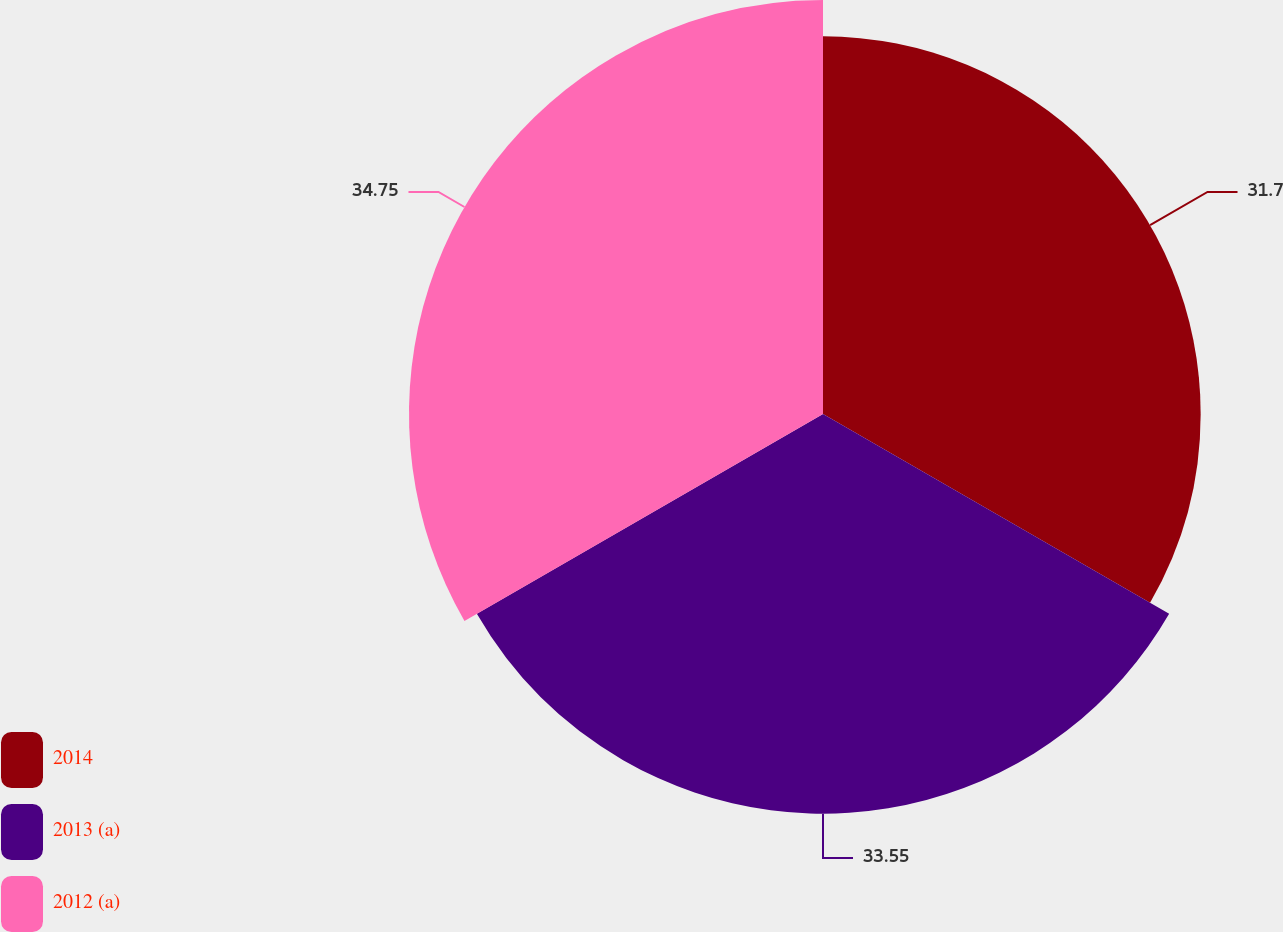Convert chart to OTSL. <chart><loc_0><loc_0><loc_500><loc_500><pie_chart><fcel>2014<fcel>2013 (a)<fcel>2012 (a)<nl><fcel>31.7%<fcel>33.55%<fcel>34.75%<nl></chart> 